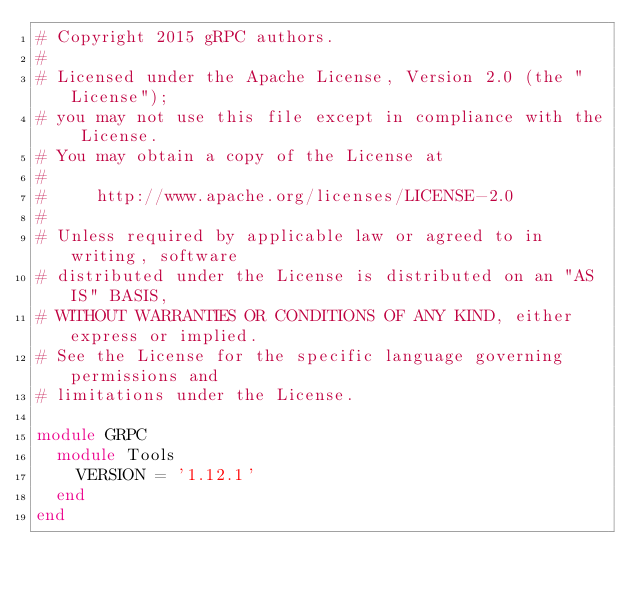<code> <loc_0><loc_0><loc_500><loc_500><_Ruby_># Copyright 2015 gRPC authors.
#
# Licensed under the Apache License, Version 2.0 (the "License");
# you may not use this file except in compliance with the License.
# You may obtain a copy of the License at
#
#     http://www.apache.org/licenses/LICENSE-2.0
#
# Unless required by applicable law or agreed to in writing, software
# distributed under the License is distributed on an "AS IS" BASIS,
# WITHOUT WARRANTIES OR CONDITIONS OF ANY KIND, either express or implied.
# See the License for the specific language governing permissions and
# limitations under the License.

module GRPC
  module Tools
    VERSION = '1.12.1'
  end
end
</code> 